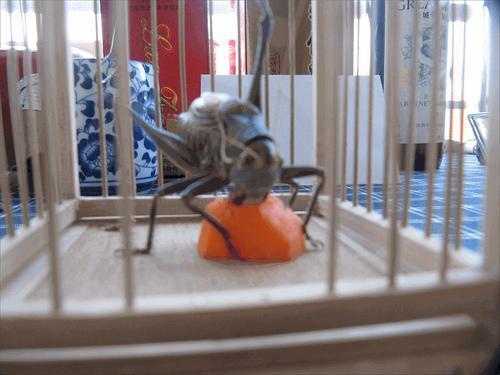How many bugs are in the photo?
Give a very brief answer. 1. How many red banners are in the background?
Give a very brief answer. 1. 